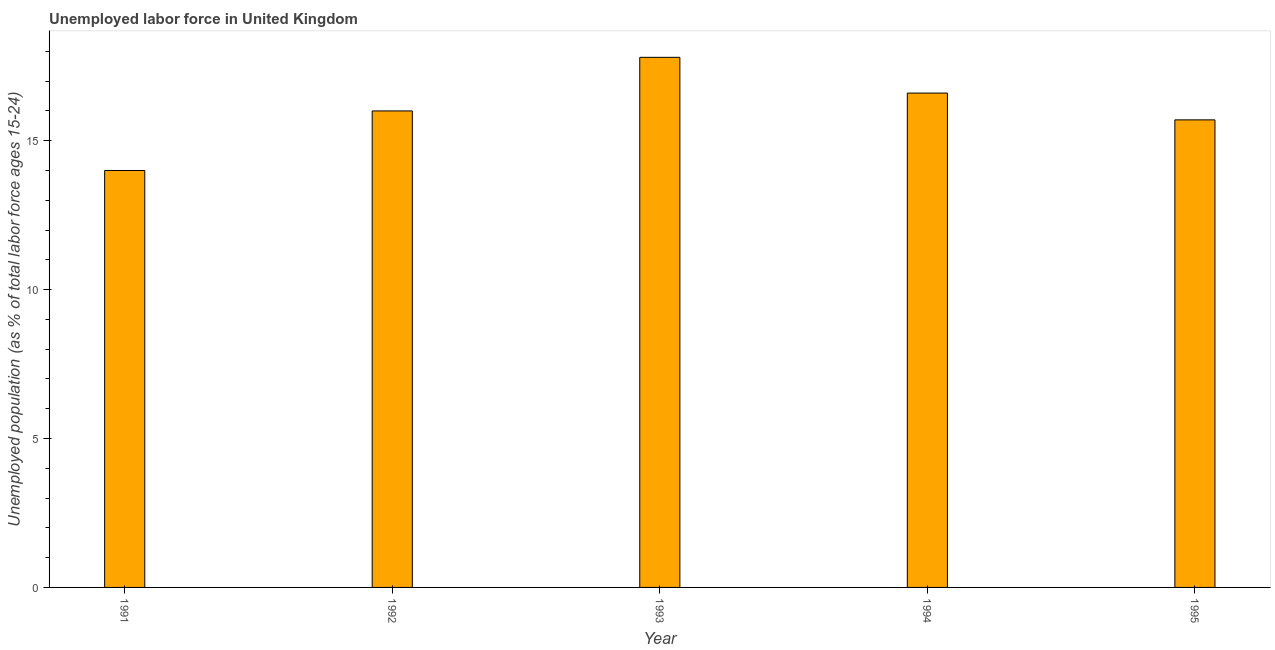Does the graph contain any zero values?
Make the answer very short. No. What is the title of the graph?
Your answer should be very brief. Unemployed labor force in United Kingdom. What is the label or title of the Y-axis?
Keep it short and to the point. Unemployed population (as % of total labor force ages 15-24). What is the total unemployed youth population in 1993?
Ensure brevity in your answer.  17.8. Across all years, what is the maximum total unemployed youth population?
Ensure brevity in your answer.  17.8. Across all years, what is the minimum total unemployed youth population?
Make the answer very short. 14. In which year was the total unemployed youth population maximum?
Your response must be concise. 1993. In which year was the total unemployed youth population minimum?
Make the answer very short. 1991. What is the sum of the total unemployed youth population?
Make the answer very short. 80.1. What is the average total unemployed youth population per year?
Ensure brevity in your answer.  16.02. What is the median total unemployed youth population?
Ensure brevity in your answer.  16. In how many years, is the total unemployed youth population greater than 8 %?
Offer a terse response. 5. What is the ratio of the total unemployed youth population in 1993 to that in 1994?
Keep it short and to the point. 1.07. What is the difference between the highest and the second highest total unemployed youth population?
Provide a succinct answer. 1.2. What is the difference between the highest and the lowest total unemployed youth population?
Make the answer very short. 3.8. In how many years, is the total unemployed youth population greater than the average total unemployed youth population taken over all years?
Your response must be concise. 2. How many bars are there?
Ensure brevity in your answer.  5. Are all the bars in the graph horizontal?
Offer a terse response. No. How many years are there in the graph?
Ensure brevity in your answer.  5. What is the Unemployed population (as % of total labor force ages 15-24) of 1992?
Ensure brevity in your answer.  16. What is the Unemployed population (as % of total labor force ages 15-24) of 1993?
Provide a short and direct response. 17.8. What is the Unemployed population (as % of total labor force ages 15-24) in 1994?
Give a very brief answer. 16.6. What is the Unemployed population (as % of total labor force ages 15-24) in 1995?
Give a very brief answer. 15.7. What is the difference between the Unemployed population (as % of total labor force ages 15-24) in 1991 and 1992?
Offer a terse response. -2. What is the difference between the Unemployed population (as % of total labor force ages 15-24) in 1991 and 1993?
Provide a succinct answer. -3.8. What is the difference between the Unemployed population (as % of total labor force ages 15-24) in 1992 and 1993?
Offer a terse response. -1.8. What is the difference between the Unemployed population (as % of total labor force ages 15-24) in 1992 and 1994?
Your answer should be compact. -0.6. What is the difference between the Unemployed population (as % of total labor force ages 15-24) in 1992 and 1995?
Make the answer very short. 0.3. What is the difference between the Unemployed population (as % of total labor force ages 15-24) in 1993 and 1994?
Your answer should be compact. 1.2. What is the difference between the Unemployed population (as % of total labor force ages 15-24) in 1993 and 1995?
Your response must be concise. 2.1. What is the difference between the Unemployed population (as % of total labor force ages 15-24) in 1994 and 1995?
Offer a terse response. 0.9. What is the ratio of the Unemployed population (as % of total labor force ages 15-24) in 1991 to that in 1992?
Provide a succinct answer. 0.88. What is the ratio of the Unemployed population (as % of total labor force ages 15-24) in 1991 to that in 1993?
Ensure brevity in your answer.  0.79. What is the ratio of the Unemployed population (as % of total labor force ages 15-24) in 1991 to that in 1994?
Keep it short and to the point. 0.84. What is the ratio of the Unemployed population (as % of total labor force ages 15-24) in 1991 to that in 1995?
Keep it short and to the point. 0.89. What is the ratio of the Unemployed population (as % of total labor force ages 15-24) in 1992 to that in 1993?
Ensure brevity in your answer.  0.9. What is the ratio of the Unemployed population (as % of total labor force ages 15-24) in 1992 to that in 1995?
Your answer should be compact. 1.02. What is the ratio of the Unemployed population (as % of total labor force ages 15-24) in 1993 to that in 1994?
Offer a very short reply. 1.07. What is the ratio of the Unemployed population (as % of total labor force ages 15-24) in 1993 to that in 1995?
Give a very brief answer. 1.13. What is the ratio of the Unemployed population (as % of total labor force ages 15-24) in 1994 to that in 1995?
Make the answer very short. 1.06. 